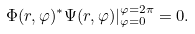Convert formula to latex. <formula><loc_0><loc_0><loc_500><loc_500>\Phi ( r , \varphi ) ^ { * } \Psi ( r , \varphi ) | _ { \varphi = 0 } ^ { \varphi = 2 \pi } = 0 .</formula> 